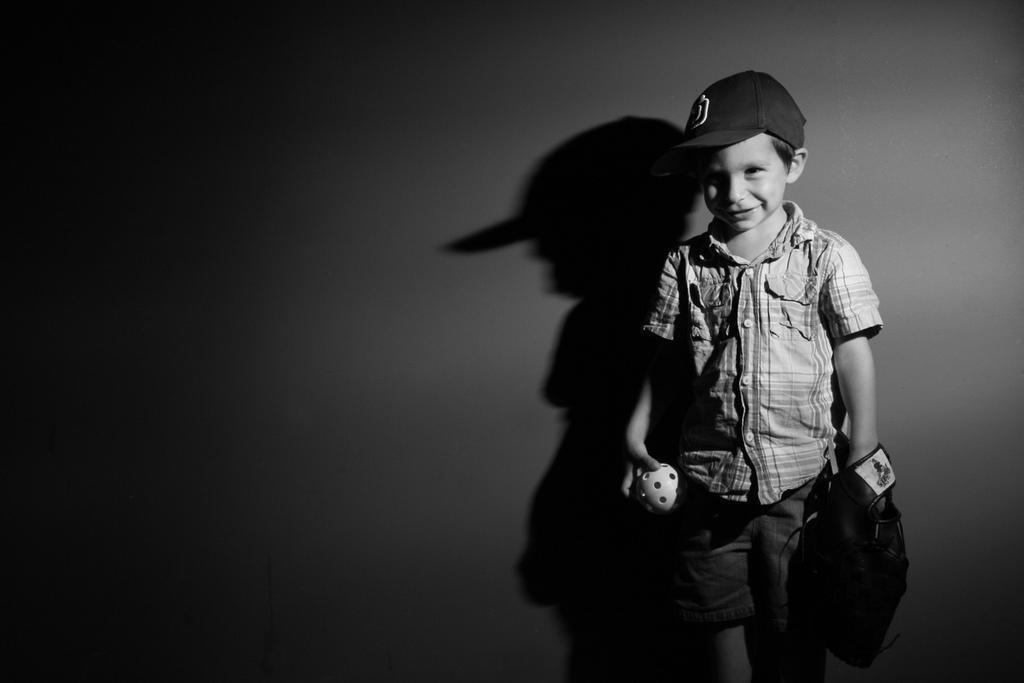What is the main subject of the picture? The main subject of the picture is a boy. What is the boy wearing on his head? The boy is wearing a cap. What type of clothing is the boy wearing on his upper body? The boy is wearing a shirt. What type of clothing is the boy wearing on his hands? The boy is wearing gloves. What type of clothing is the boy wearing on his lower body? The boy is wearing shorts. What is the boy's facial expression in the picture? The boy is smiling. What object is the boy holding in the picture? The boy is holding a ball. Can you describe the shadow in the picture? There is a shadow of the boy on the wall. What type of respect can be seen in the image? There is no indication of respect in the image; it features a boy wearing various clothing items, smiling, and holding a ball. What is the texture of the wall in the image? The provided facts do not mention the texture of the wall, only the presence of the boy's shadow on it. 